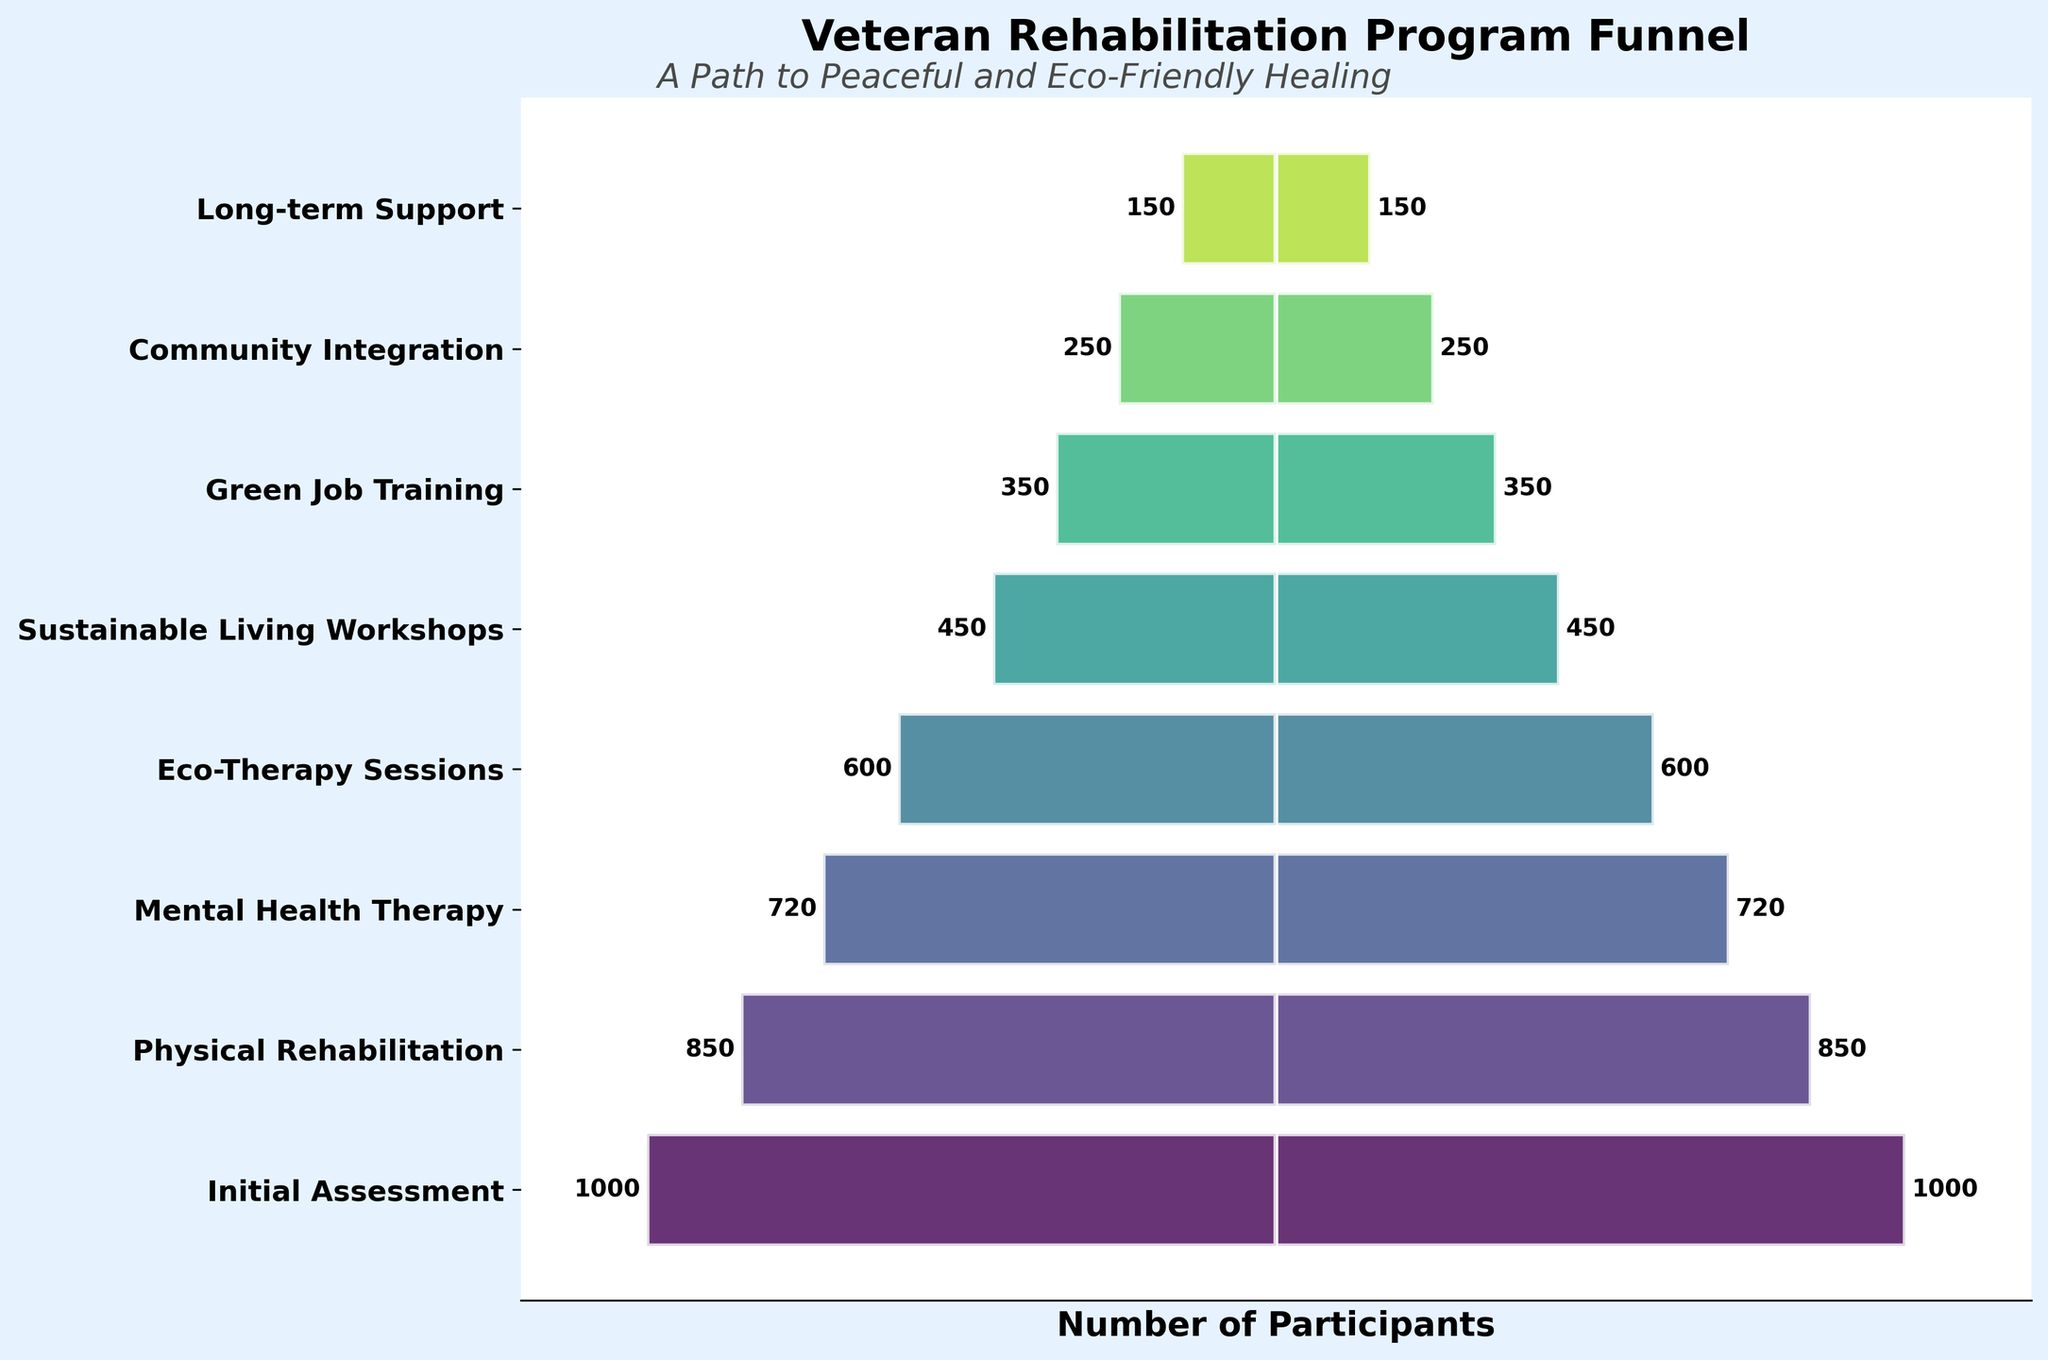What is the title of the funnel chart? The title of the chart is displayed at the top of the figure and summarizes the information presented.
Answer: Veteran Rehabilitation Program Funnel Which stage has the highest number of participants? The topmost bar represents the stage with the maximum width, indicating the highest number of participants.
Answer: Initial Assessment How many participants are there in the Eco-Therapy Sessions stage? Find the Eco-Therapy Sessions label on the y-axis and read the corresponding value from the chart.
Answer: 600 Which stage sees the largest drop in the number of participants compared to the previous stage? Calculate the differences between the participants of successive stages, then identify the largest difference. The largest drop is between Sustainable Living Workshops (450) and Green Job Training (350), which is 100.
Answer: Sustainable Living Workshops to Green Job Training What is the total number of participants from the Green Job Training stage onward? Sum the number of participants from the Green Job Training, Community Integration, and Long-term Support stages (350 + 250 + 150).
Answer: 750 How many stages have more than 500 participants? Count the number of stages where the participant values exceed 500. These stages are Initial Assessment (1000), Physical Rehabilitation (850), Mental Health Therapy (720), and Eco-Therapy Sessions (600).
Answer: 4 What is the average number of participants across all stages? Sum the number of participants across all stages and divide by the number of stages (8). Calculations: (1000 + 850 + 720 + 600 + 450 + 350 + 250 + 150) / 8 = 4370 / 8 = 546.25.
Answer: 546.25 Between which stages do we have exactly a 200 participant drop? Find the stages where the difference between their participant numbers is 200. The only such stages are Eco-Therapy Sessions (600) and Sustainable Living Workshops (450).
Answer: Eco-Therapy Sessions to Sustainable Living Workshops What color represents the Mental Health Therapy stage in the chart? Observe the color used for the Mental Health Therapy stage bar positioned on the y-axis and recognize its color by comparison to other stages.
Answer: A shade of green (since viridis colormap is used) Order the stages with the least to the most number of participants. List the stages in ascending order based on their participant numbers.
Answer: Long-term Support, Community Integration, Green Job Training, Sustainable Living Workshops, Eco-Therapy Sessions, Mental Health Therapy, Physical Rehabilitation, Initial Assessment 